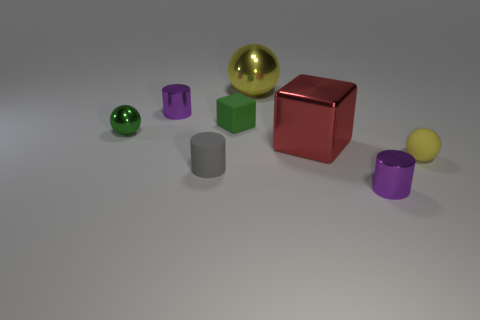Are there any large spheres of the same color as the big block?
Offer a terse response. No. There is a gray matte cylinder; is it the same size as the yellow object that is to the left of the metal cube?
Keep it short and to the point. No. What number of yellow things are right of the large red shiny thing in front of the large yellow shiny ball that is right of the small gray object?
Provide a short and direct response. 1. The sphere that is the same color as the small matte cube is what size?
Keep it short and to the point. Small. Are there any matte balls on the left side of the small green matte cube?
Ensure brevity in your answer.  No. What shape is the small gray object?
Provide a short and direct response. Cylinder. What is the shape of the large object that is behind the purple cylinder on the left side of the purple thing on the right side of the small block?
Keep it short and to the point. Sphere. What number of other things are the same shape as the small yellow object?
Your answer should be compact. 2. What is the material of the yellow sphere that is to the right of the metallic sphere behind the green matte block?
Keep it short and to the point. Rubber. Are there any other things that are the same size as the gray cylinder?
Offer a very short reply. Yes. 